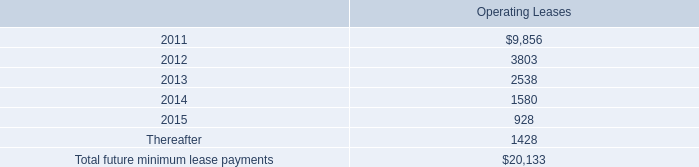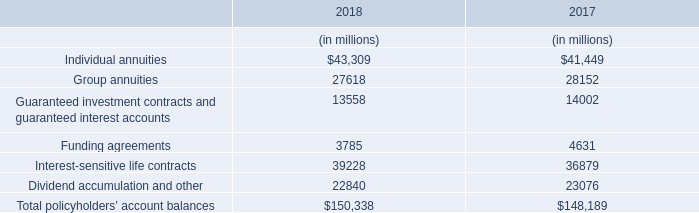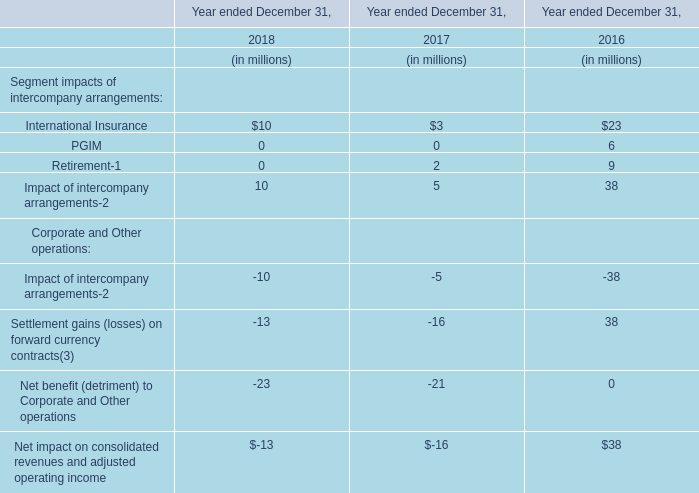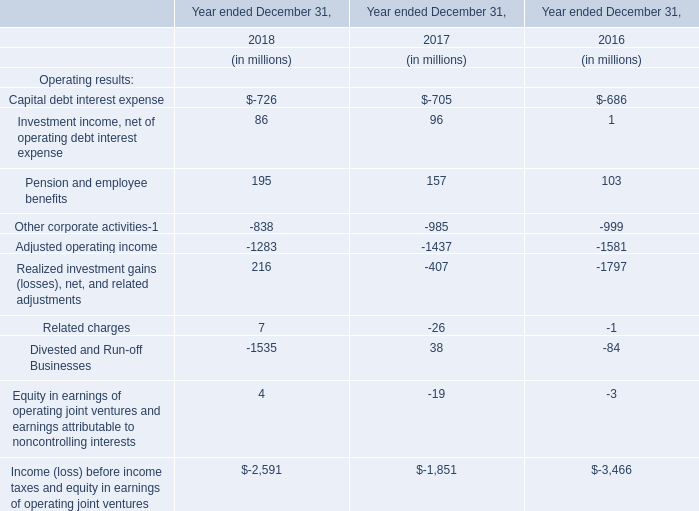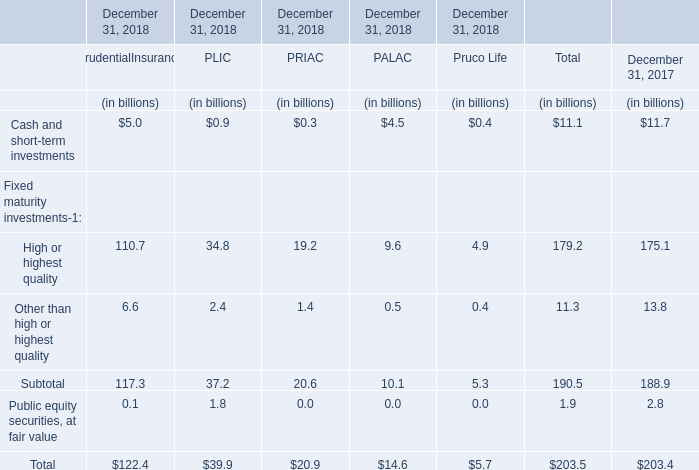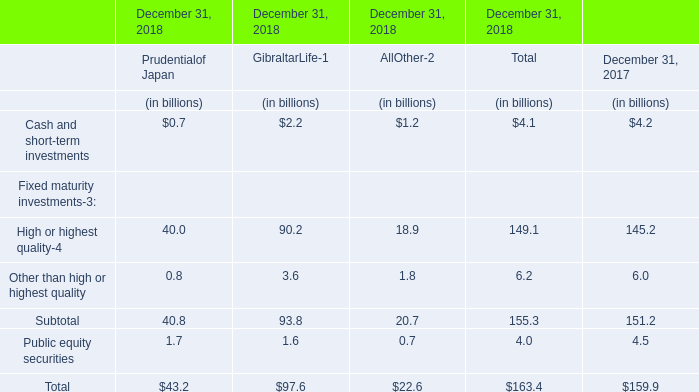What will High or highest quality be like in 2019 if it develops with the same increasing rate as current? (in billion) 
Computations: (179.2 * (1 + ((179.2 - 175.1) / 175.1)))
Answer: 183.396. 